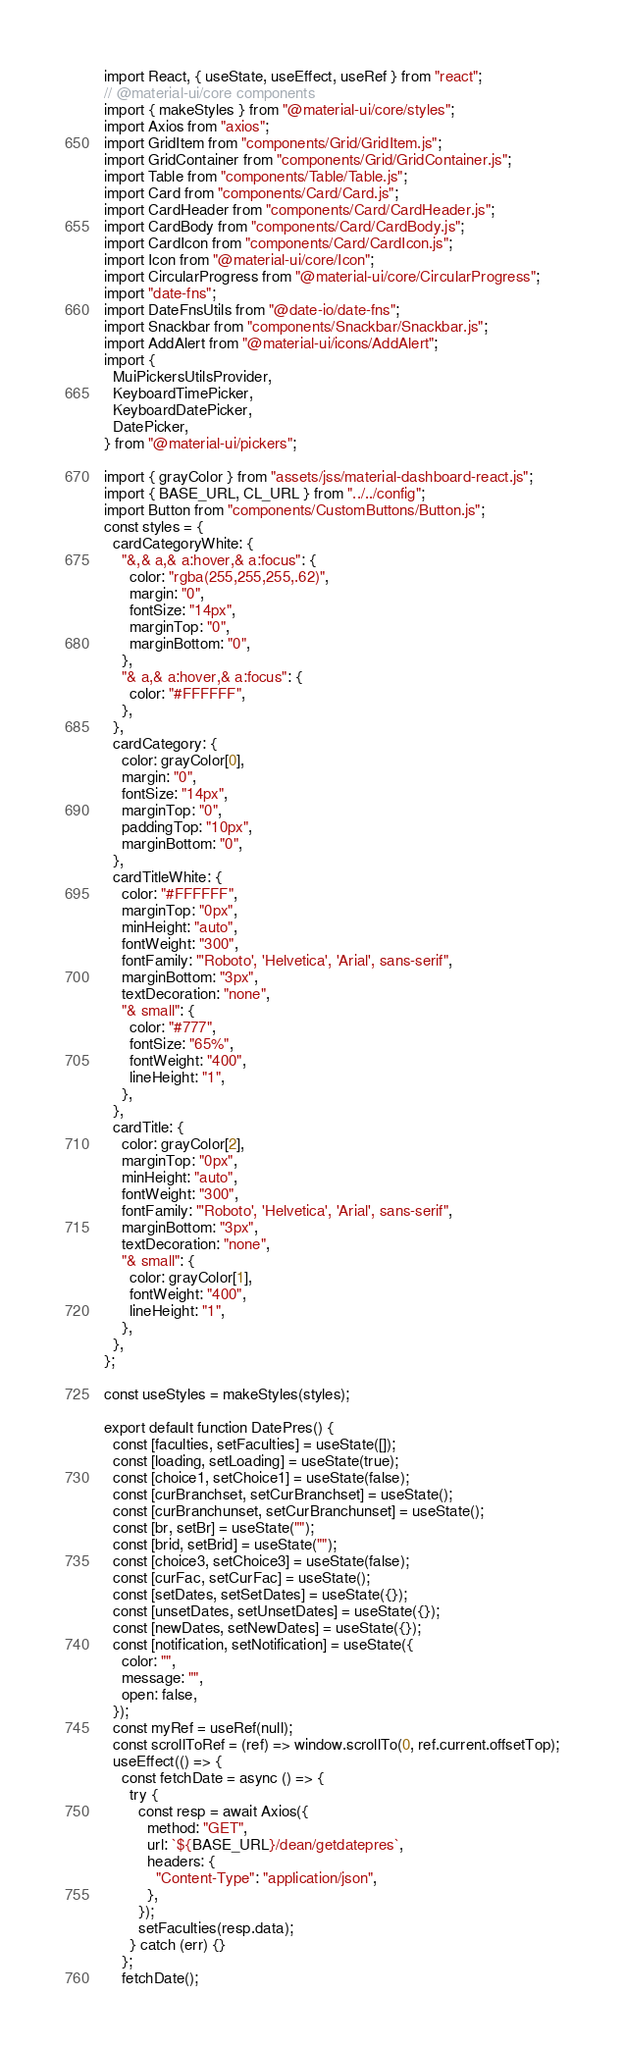Convert code to text. <code><loc_0><loc_0><loc_500><loc_500><_JavaScript_>import React, { useState, useEffect, useRef } from "react";
// @material-ui/core components
import { makeStyles } from "@material-ui/core/styles";
import Axios from "axios";
import GridItem from "components/Grid/GridItem.js";
import GridContainer from "components/Grid/GridContainer.js";
import Table from "components/Table/Table.js";
import Card from "components/Card/Card.js";
import CardHeader from "components/Card/CardHeader.js";
import CardBody from "components/Card/CardBody.js";
import CardIcon from "components/Card/CardIcon.js";
import Icon from "@material-ui/core/Icon";
import CircularProgress from "@material-ui/core/CircularProgress";
import "date-fns";
import DateFnsUtils from "@date-io/date-fns";
import Snackbar from "components/Snackbar/Snackbar.js";
import AddAlert from "@material-ui/icons/AddAlert";
import {
  MuiPickersUtilsProvider,
  KeyboardTimePicker,
  KeyboardDatePicker,
  DatePicker,
} from "@material-ui/pickers";

import { grayColor } from "assets/jss/material-dashboard-react.js";
import { BASE_URL, CL_URL } from "../../config";
import Button from "components/CustomButtons/Button.js";
const styles = {
  cardCategoryWhite: {
    "&,& a,& a:hover,& a:focus": {
      color: "rgba(255,255,255,.62)",
      margin: "0",
      fontSize: "14px",
      marginTop: "0",
      marginBottom: "0",
    },
    "& a,& a:hover,& a:focus": {
      color: "#FFFFFF",
    },
  },
  cardCategory: {
    color: grayColor[0],
    margin: "0",
    fontSize: "14px",
    marginTop: "0",
    paddingTop: "10px",
    marginBottom: "0",
  },
  cardTitleWhite: {
    color: "#FFFFFF",
    marginTop: "0px",
    minHeight: "auto",
    fontWeight: "300",
    fontFamily: "'Roboto', 'Helvetica', 'Arial', sans-serif",
    marginBottom: "3px",
    textDecoration: "none",
    "& small": {
      color: "#777",
      fontSize: "65%",
      fontWeight: "400",
      lineHeight: "1",
    },
  },
  cardTitle: {
    color: grayColor[2],
    marginTop: "0px",
    minHeight: "auto",
    fontWeight: "300",
    fontFamily: "'Roboto', 'Helvetica', 'Arial', sans-serif",
    marginBottom: "3px",
    textDecoration: "none",
    "& small": {
      color: grayColor[1],
      fontWeight: "400",
      lineHeight: "1",
    },
  },
};

const useStyles = makeStyles(styles);

export default function DatePres() {
  const [faculties, setFaculties] = useState([]);
  const [loading, setLoading] = useState(true);
  const [choice1, setChoice1] = useState(false);
  const [curBranchset, setCurBranchset] = useState();
  const [curBranchunset, setCurBranchunset] = useState();
  const [br, setBr] = useState("");
  const [brid, setBrid] = useState("");
  const [choice3, setChoice3] = useState(false);
  const [curFac, setCurFac] = useState();
  const [setDates, setSetDates] = useState({});
  const [unsetDates, setUnsetDates] = useState({});
  const [newDates, setNewDates] = useState({});
  const [notification, setNotification] = useState({
    color: "",
    message: "",
    open: false,
  });
  const myRef = useRef(null);
  const scrollToRef = (ref) => window.scrollTo(0, ref.current.offsetTop);
  useEffect(() => {
    const fetchDate = async () => {
      try {
        const resp = await Axios({
          method: "GET",
          url: `${BASE_URL}/dean/getdatepres`,
          headers: {
            "Content-Type": "application/json",
          },
        });
        setFaculties(resp.data);
      } catch (err) {}
    };
    fetchDate();</code> 